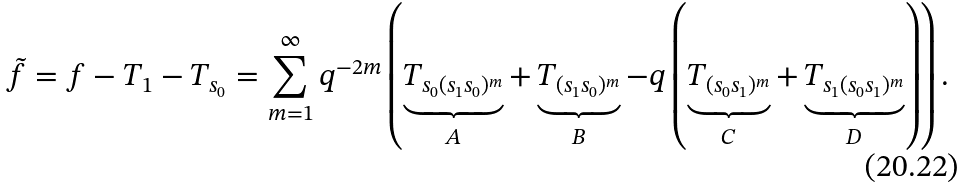Convert formula to latex. <formula><loc_0><loc_0><loc_500><loc_500>\tilde { f } = f - T _ { 1 } - T _ { s _ { 0 } } = \sum _ { m = 1 } ^ { \infty } q ^ { - 2 m } \left ( \underbrace { T _ { s _ { 0 } ( s _ { 1 } s _ { 0 } ) ^ { m } } } _ { A } + \underbrace { T _ { ( s _ { 1 } s _ { 0 } ) ^ { m } } } _ { B } - q \left ( \underbrace { T _ { ( s _ { 0 } s _ { 1 } ) ^ { m } } } _ { C } + \underbrace { T _ { s _ { 1 } ( s _ { 0 } s _ { 1 } ) ^ { m } } } _ { D } \right ) \right ) .</formula> 